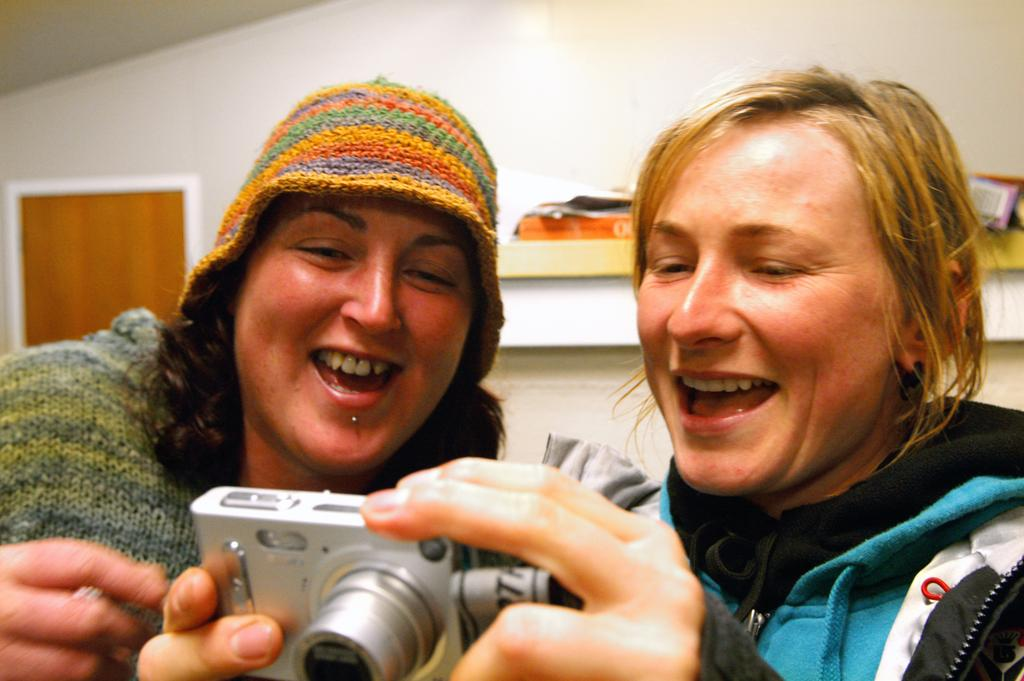How many people are in the image? There are two persons in the image. What is one of the persons doing in the image? One person is holding a camera. Can you describe the appearance of the person holding the camera? The person holding the camera is wearing a cap. What can be seen in the background of the image? There is a wall and books in the background of the image. What type of blood is visible on the person's hands in the image? There is no blood visible on anyone's hands in the image. What is being served for dinner in the image? There is no dinner or food being served in the image. 